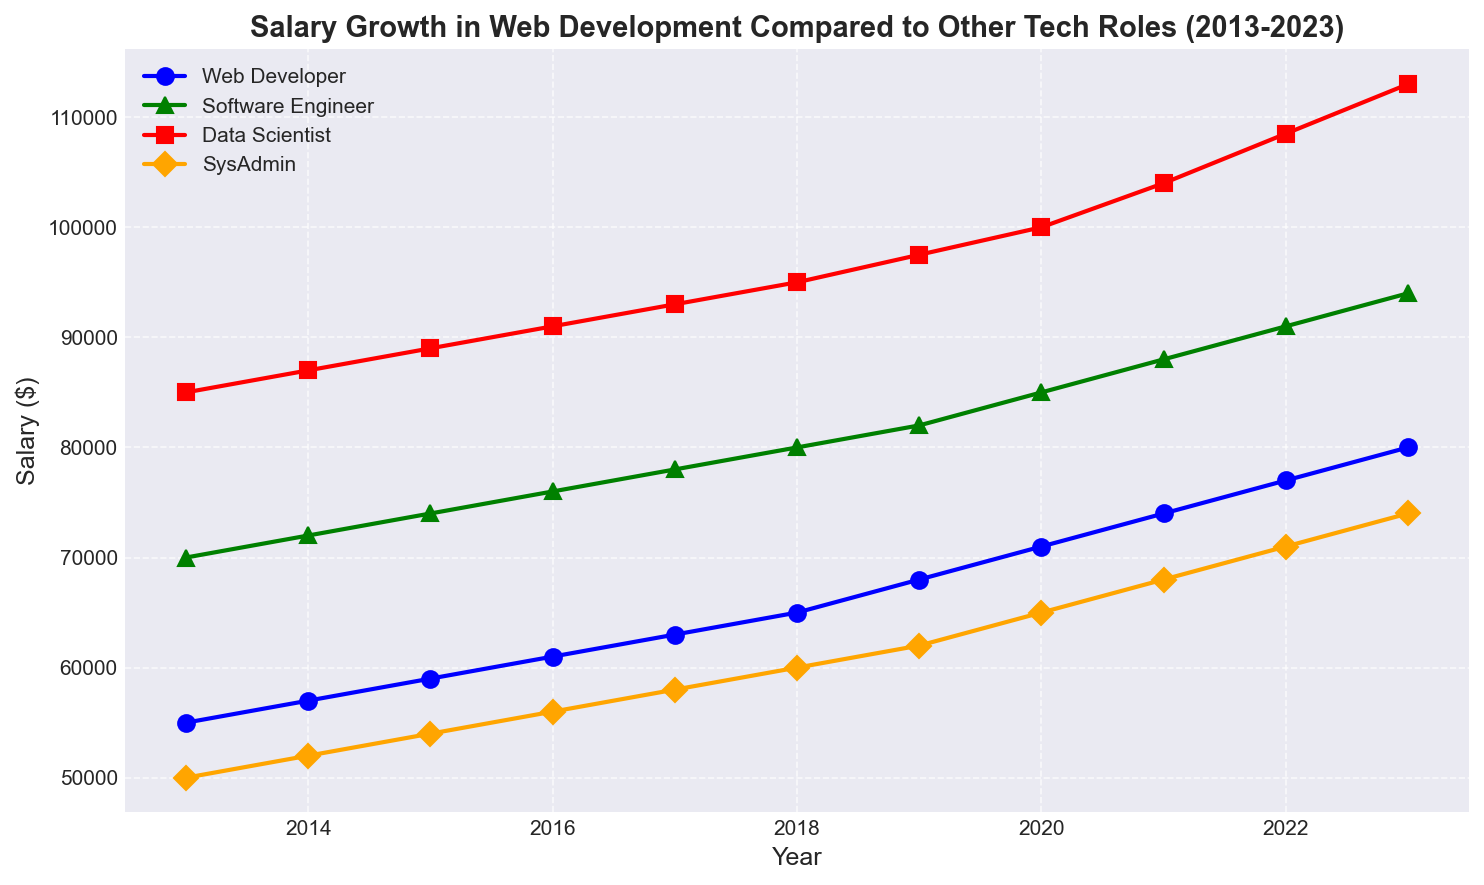what is the salary gap between Data Scientists and Web Developers in 2023? The salary of Data Scientists in 2023 is $113000 and for Web Developers it is $80000. The difference between the two is calculated as 113000 - 80000.
Answer: $33000 Which role saw the highest salary increase from 2013 to 2023? By examining the figure, we see that Web Developers increased from $55000 in 2013 to $80000 in 2023, Software Engineers from $70000 to $94000, Data Scientists from $85000 to $113000, and SysAdmins from $50000 to $74000. Data Scientists saw the highest increase of $28000.
Answer: Data Scientist Between 2020 and 2021, which role had the largest salary growth percentage-wise? For Web Developers, the growth rate from 2020 to 2021 is ((74000 - 71000) / 71000) * 100 = ~4.2%. For Software Engineers, it is ((88000 - 85000) / 85000) * 100 = ~3.5%. For Data Scientists, it is ((104000 - 100000) / 100000) * 100 = ~4%. For SysAdmins, it is ((68000 - 65000) / 65000) * 100 = ~4.6%.
Answer: SysAdmin What is the average salary of Software Engineers between 2013 and 2023? Sum the salaries for Software Engineers from 2013 to 2023: 70000 + 72000 + 74000 + 76000 + 78000 + 80000 + 82000 + 85000 + 88000 + 91000 + 94000 = 850000. Divide by the number of years (11).
Answer: $77272.73 In which year did the salary of Web Developers first surpass $60000? By referring to the figure, we can see the salary of Web Developers in 2015 was $59000 and in 2016 it was $61000. Therefore, it surpassed $60000 in 2016.
Answer: 2016 Which role has the most steady salary growth over the decade? By looking at the slopes of the lines in the figure, we can see that the Web Developer role has a very steady and consistent increase each year without any sharp spikes or dips, indicating steady growth.
Answer: Web Developer Compare the salaries of Web Developers and Software Engineers in 2018. Which one is higher and by how much? In 2018, the salary for Web Developers is $65000, and for Software Engineers it is $80000. The difference is calculated as 80000 - 65000.
Answer: Software Engineer by $15000 From 2017 to 2023, which role's salary grew the slowest in absolute numbers? Analyzing the figure, the salary growth for Web Developers is 80000 - 63000 = $17000, for Software Engineers it is 94000 - 78000 = $16000, for Data Scientists it is 113000 - 93000 = $20000, and for SysAdmins it is 74000 - 58000 = $16000. Both Software Engineers and SysAdmins had the slowest growth of $16000.
Answer: Software Engineer and SysAdmin 